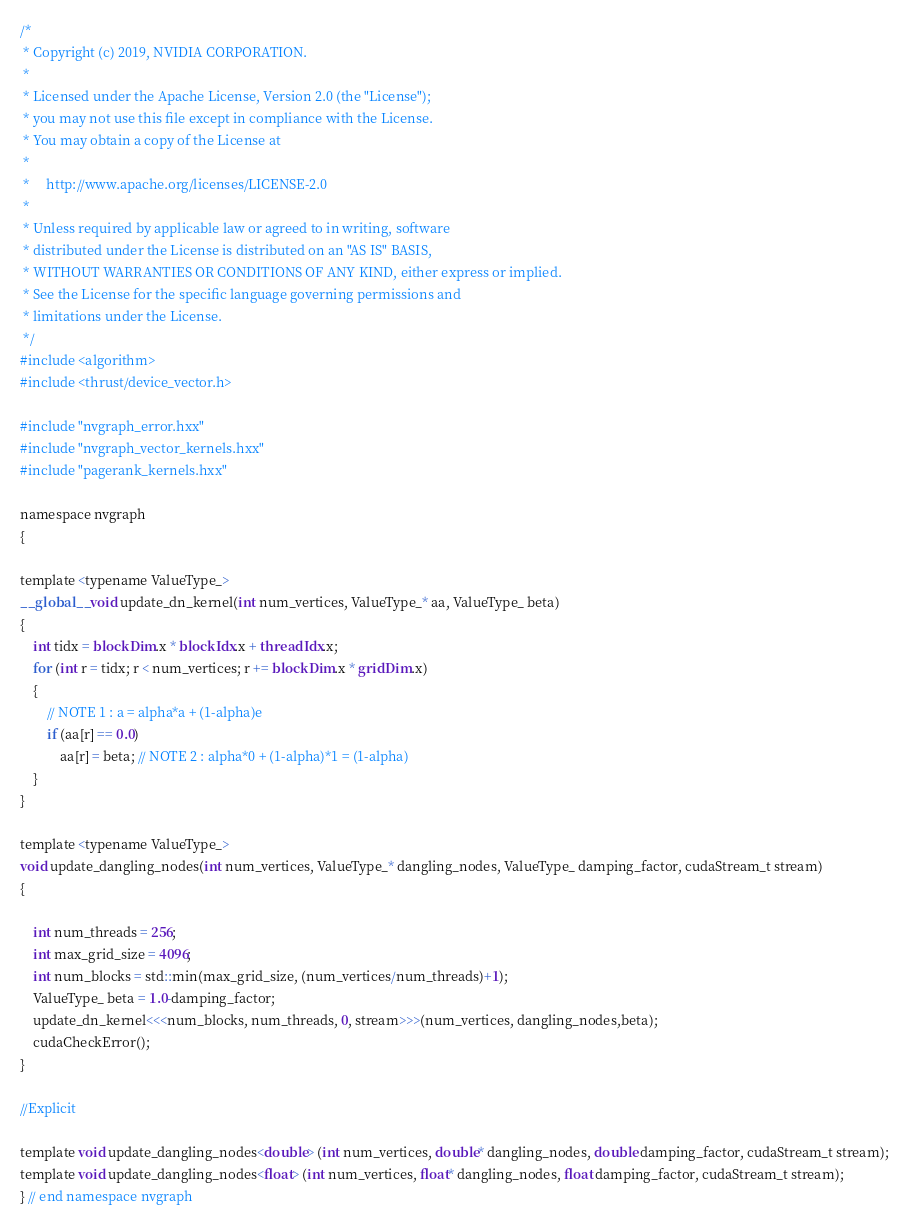<code> <loc_0><loc_0><loc_500><loc_500><_Cuda_>/*
 * Copyright (c) 2019, NVIDIA CORPORATION.
 *
 * Licensed under the Apache License, Version 2.0 (the "License");
 * you may not use this file except in compliance with the License.
 * You may obtain a copy of the License at
 *
 *     http://www.apache.org/licenses/LICENSE-2.0
 *
 * Unless required by applicable law or agreed to in writing, software
 * distributed under the License is distributed on an "AS IS" BASIS,
 * WITHOUT WARRANTIES OR CONDITIONS OF ANY KIND, either express or implied.
 * See the License for the specific language governing permissions and
 * limitations under the License.
 */
#include <algorithm>
#include <thrust/device_vector.h>

#include "nvgraph_error.hxx"
#include "nvgraph_vector_kernels.hxx"
#include "pagerank_kernels.hxx"

namespace nvgraph
{

template <typename ValueType_>
__global__ void update_dn_kernel(int num_vertices, ValueType_* aa, ValueType_ beta)
{
    int tidx = blockDim.x * blockIdx.x + threadIdx.x;
    for (int r = tidx; r < num_vertices; r += blockDim.x * gridDim.x)
    {
        // NOTE 1 : a = alpha*a + (1-alpha)e
        if (aa[r] == 0.0)
            aa[r] = beta; // NOTE 2 : alpha*0 + (1-alpha)*1 = (1-alpha)
    }
}

template <typename ValueType_>
void update_dangling_nodes(int num_vertices, ValueType_* dangling_nodes, ValueType_ damping_factor, cudaStream_t stream)
{
	
	int num_threads = 256;
    int max_grid_size = 4096;
    int num_blocks = std::min(max_grid_size, (num_vertices/num_threads)+1);
    ValueType_ beta = 1.0-damping_factor;
    update_dn_kernel<<<num_blocks, num_threads, 0, stream>>>(num_vertices, dangling_nodes,beta);
    cudaCheckError();
}

//Explicit

template void update_dangling_nodes<double> (int num_vertices, double* dangling_nodes, double damping_factor, cudaStream_t stream);
template void update_dangling_nodes<float> (int num_vertices, float* dangling_nodes, float damping_factor, cudaStream_t stream);
} // end namespace nvgraph

</code> 